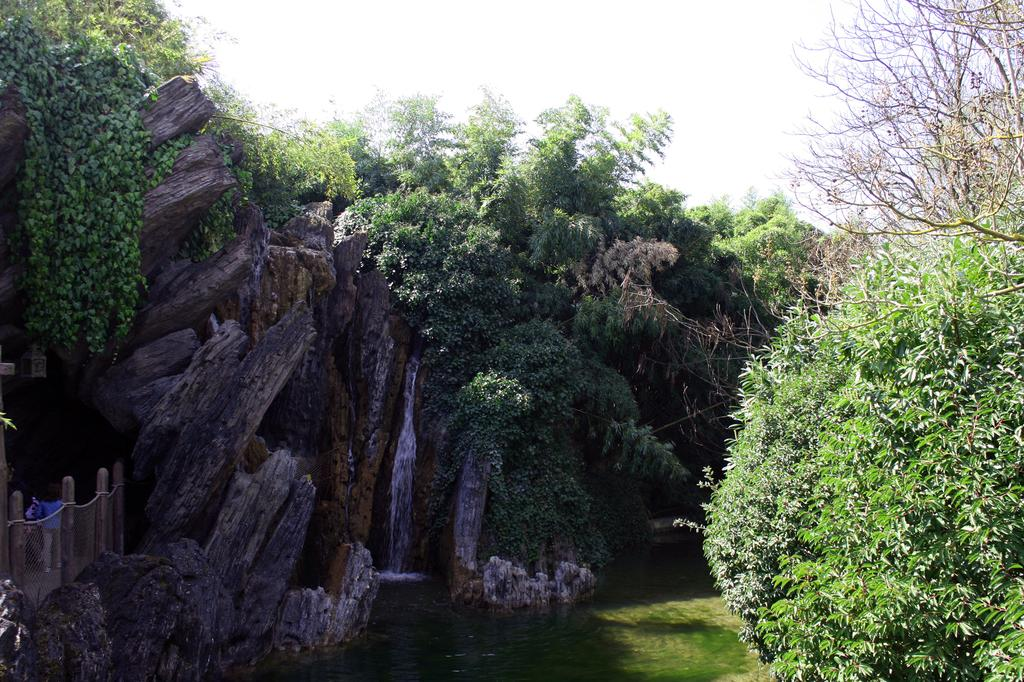What is located in the middle of the image? There are trees in the middle of the image. What can be seen at the bottom of the image? There is water at the bottom of the image. Where is the bridge in the image? The bridge is on the left side of the image. What is the person in the image doing? There is a person walking across the bridge. What is visible at the top of the image? The sky is visible at the top of the image. What type of statement is being made by the needle in the image? There is no needle present in the image. What color is the ink used by the person walking across the bridge? There is no ink or reference to writing in the image. 